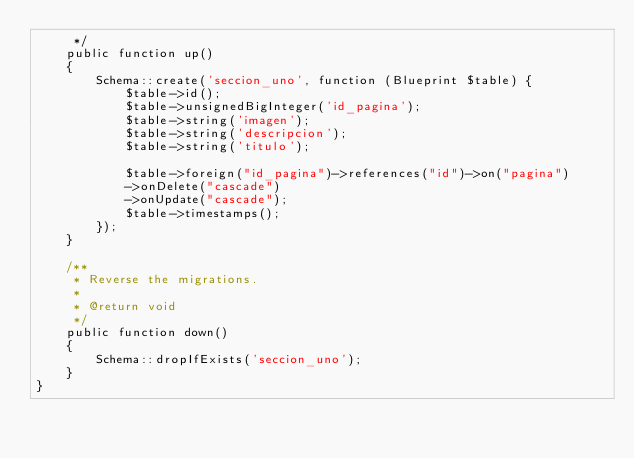<code> <loc_0><loc_0><loc_500><loc_500><_PHP_>     */
    public function up()
    {
        Schema::create('seccion_uno', function (Blueprint $table) {
            $table->id();
            $table->unsignedBigInteger('id_pagina');
            $table->string('imagen');
            $table->string('descripcion');
            $table->string('titulo');

            $table->foreign("id_pagina")->references("id")->on("pagina")
            ->onDelete("cascade")
            ->onUpdate("cascade");
            $table->timestamps();
        });
    }

    /**
     * Reverse the migrations.
     *
     * @return void
     */
    public function down()
    {
        Schema::dropIfExists('seccion_uno');
    }
}
</code> 